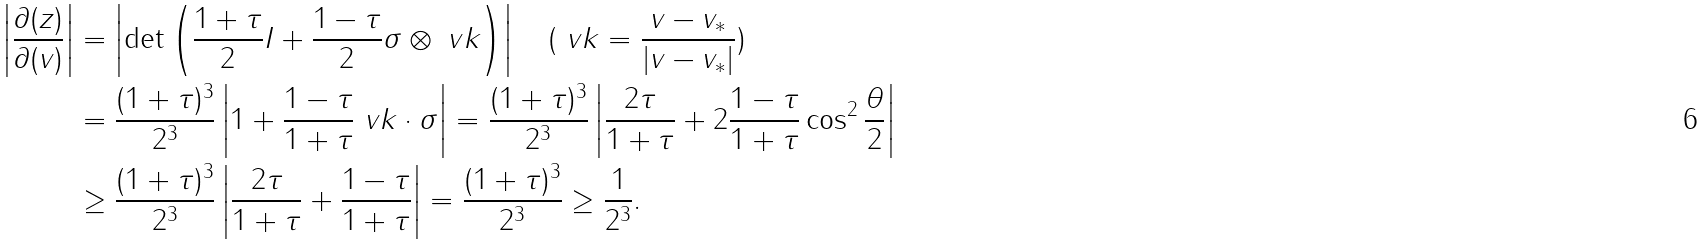Convert formula to latex. <formula><loc_0><loc_0><loc_500><loc_500>\left | \frac { \partial ( z ) } { \partial ( v ) } \right | & = \left | \text {det} \left ( \frac { 1 + \tau } { 2 } I + \frac { 1 - \tau } { 2 } \sigma \otimes \ v k \right ) \right | \quad ( \ v k = \frac { v - v _ { * } } { | v - v _ { * } | } ) \\ & = \frac { ( 1 + \tau ) ^ { 3 } } { 2 ^ { 3 } } \left | 1 + \frac { 1 - \tau } { 1 + \tau } \ v k \cdot \sigma \right | = \frac { ( 1 + \tau ) ^ { 3 } } { 2 ^ { 3 } } \left | \frac { 2 \tau } { 1 + \tau } + 2 \frac { 1 - \tau } { 1 + \tau } \cos ^ { 2 } \frac { \theta } { 2 } \right | \\ & \geq \frac { ( 1 + \tau ) ^ { 3 } } { 2 ^ { 3 } } \left | \frac { 2 \tau } { 1 + \tau } + \frac { 1 - \tau } { 1 + \tau } \right | = \frac { ( 1 + \tau ) ^ { 3 } } { 2 ^ { 3 } } \geq \frac { 1 } { 2 ^ { 3 } } .</formula> 